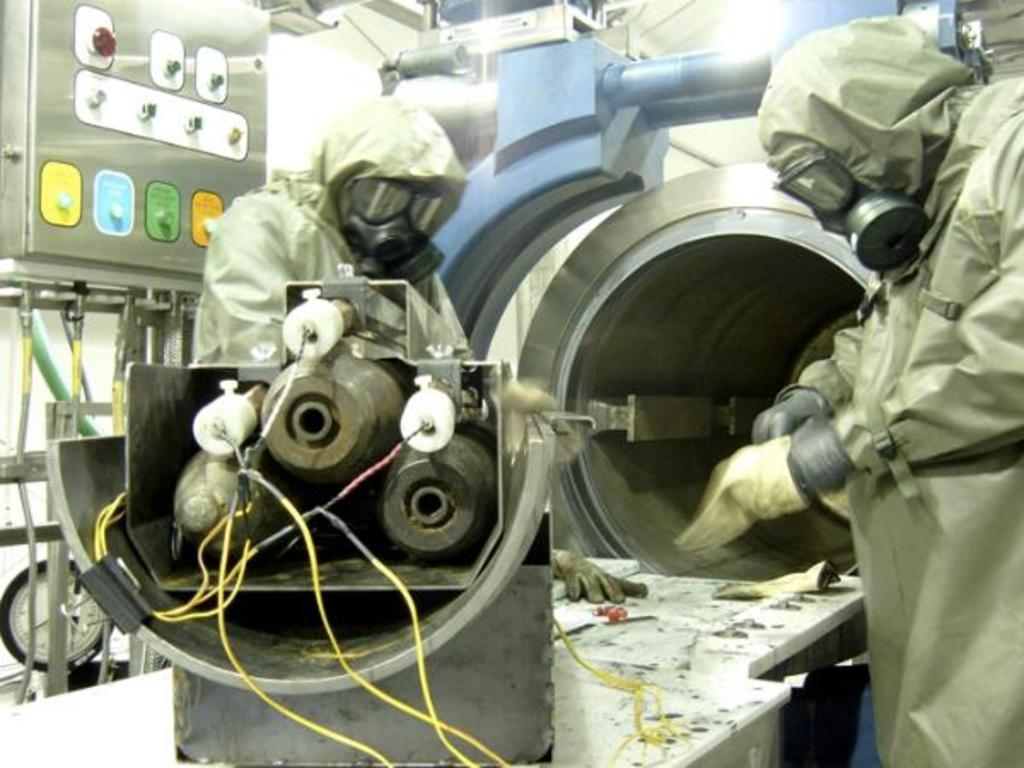How many people are in the image? There are two persons standing in the image. What are the people wearing on their hands? Both persons are wearing gloves. What type of protective gear are the people wearing on their faces? Both persons are wearing gas masks. What type of clothing are the people wearing on their upper bodies? Both persons are wearing coats. What equipment can be seen in the image? There are multiple pieces of equipment visible in the image. Can you hear the sound of a bridge in the image? There is no bridge present in the image, and therefore no sound can be heard. Is there a faucet visible in the image? There is no faucet present in the image. 